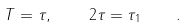<formula> <loc_0><loc_0><loc_500><loc_500>T = \tau , \quad 2 \tau = \tau _ { 1 } \quad .</formula> 